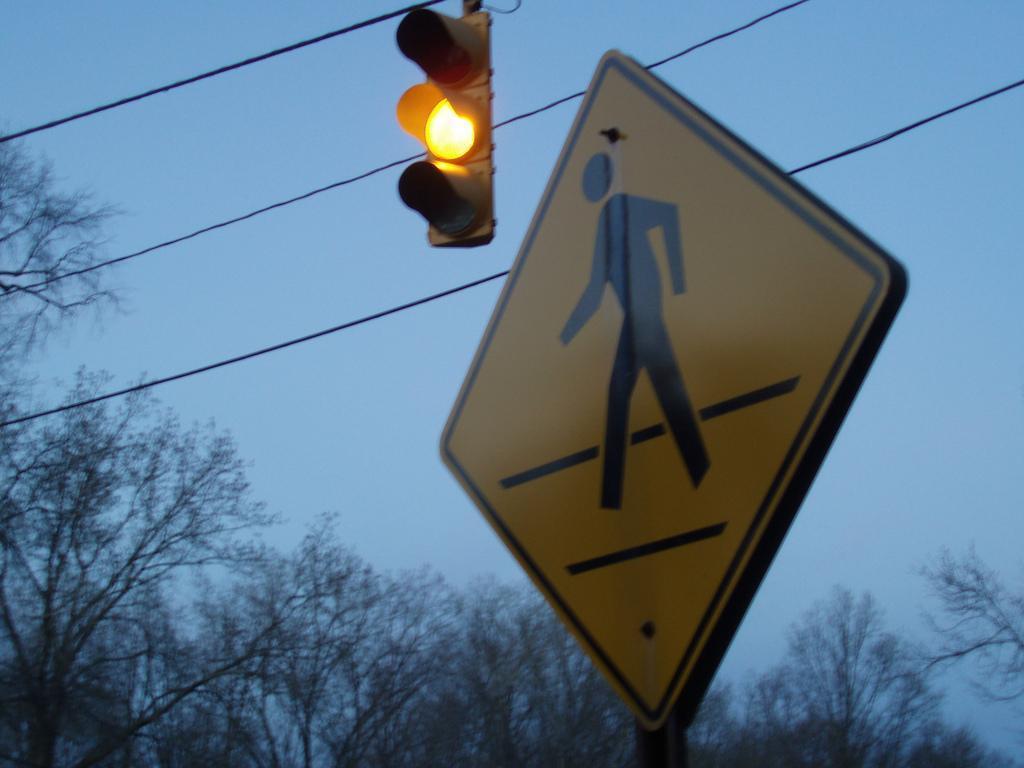How many signs are there?
Give a very brief answer. 1. How many signs are in the pic?
Give a very brief answer. 1. How many power lines are there?
Give a very brief answer. 3. How many black wires are there?
Give a very brief answer. 3. 